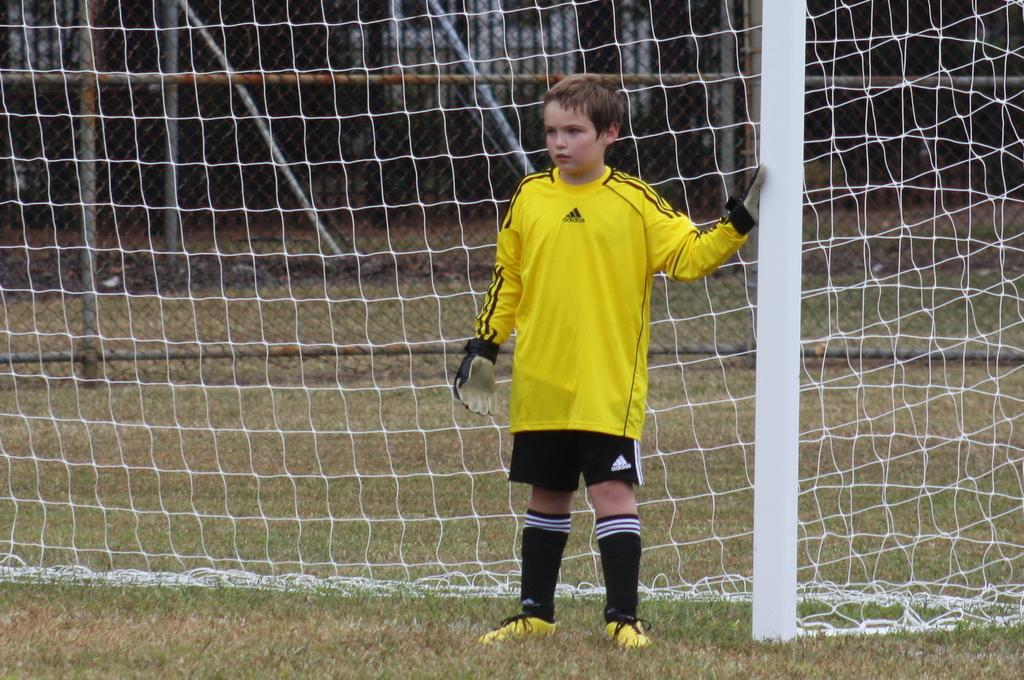What is the main subject of the image? The main subject of the image is a kid. Where is the kid located in the image? The kid is standing in front of a goal post. What type of plate is being used to generate heat in the image? There is no plate or heat generation present in the image; it features a kid standing in front of a goal post. 